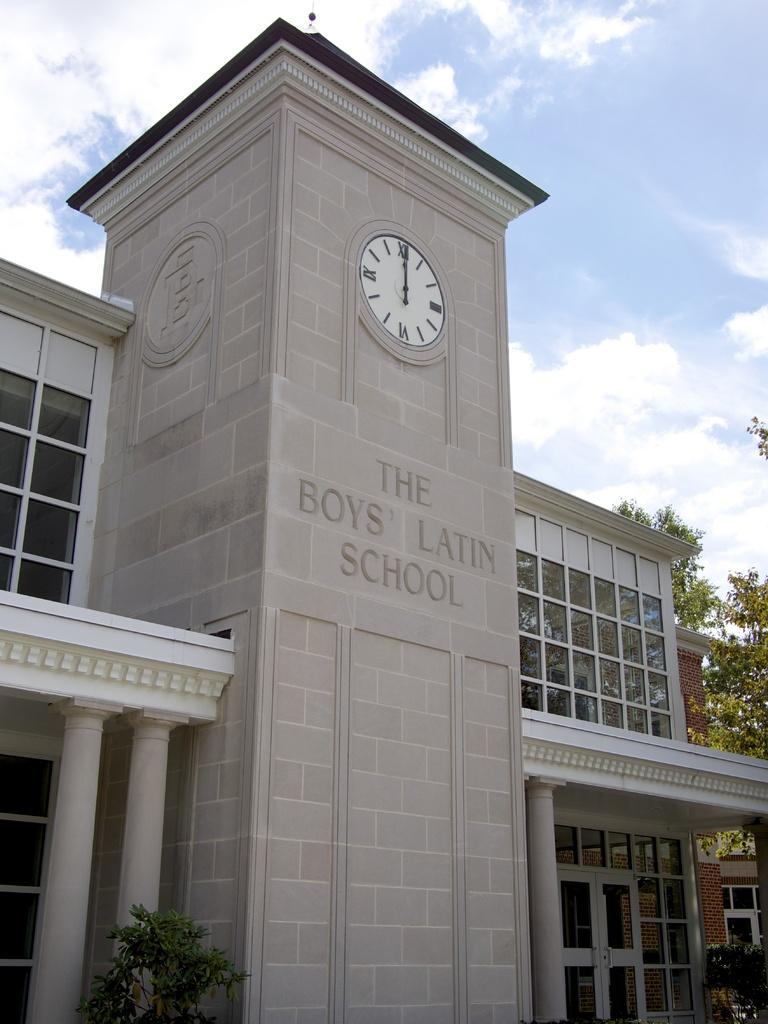<image>
Relay a brief, clear account of the picture shown. The front of The Boys' Latin School building has a clock on it. 